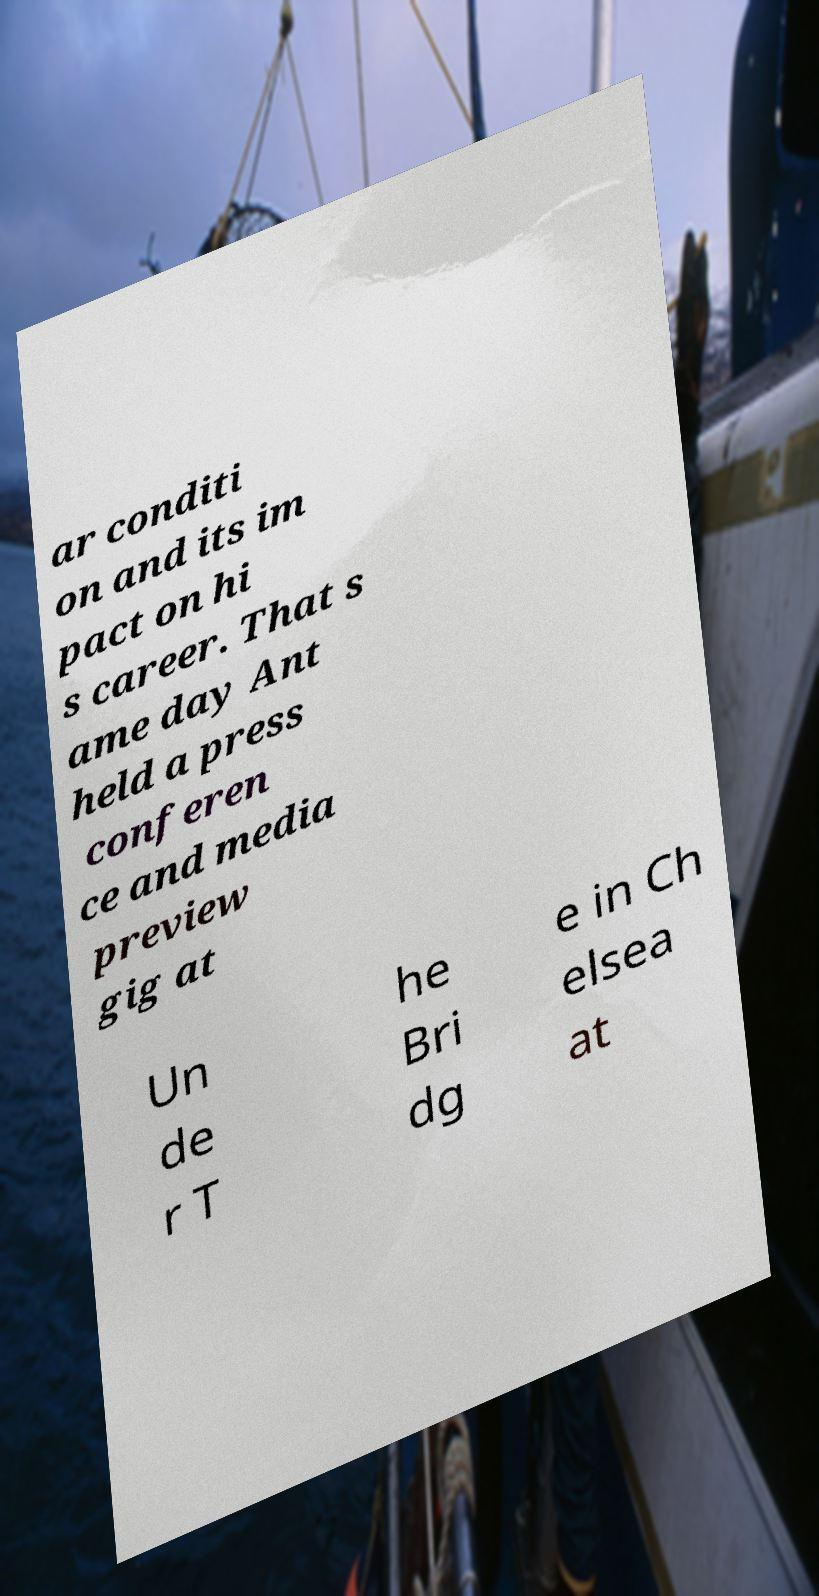For documentation purposes, I need the text within this image transcribed. Could you provide that? ar conditi on and its im pact on hi s career. That s ame day Ant held a press conferen ce and media preview gig at Un de r T he Bri dg e in Ch elsea at 